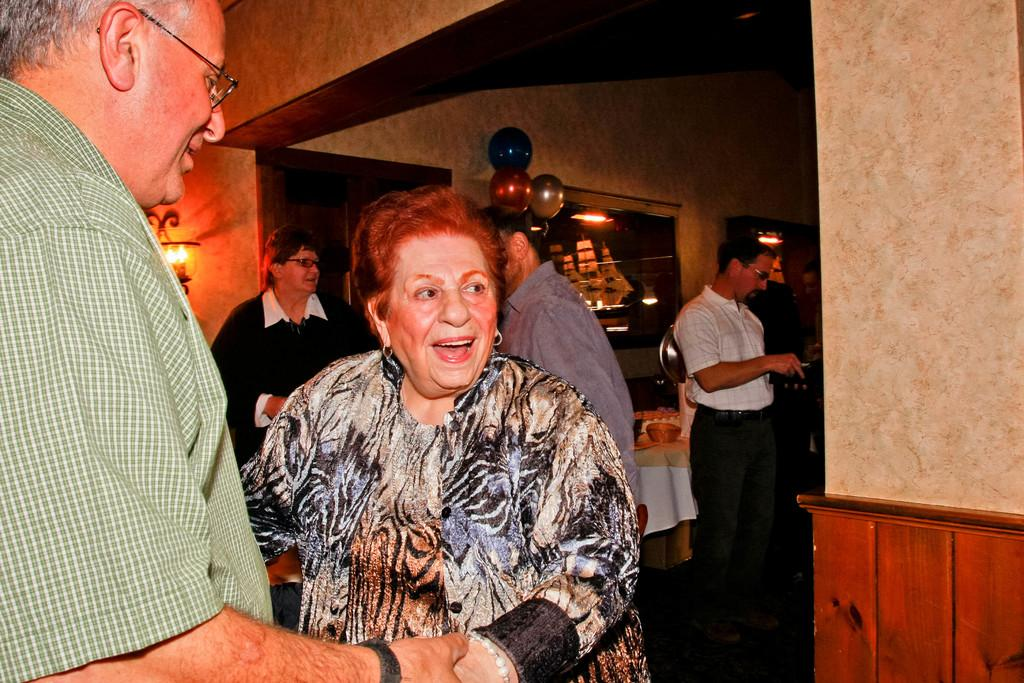How many persons can be seen in the image? There are persons standing in the image. What surface are the persons standing on? The persons are standing on the floor. What decorative item is hanging on a wall in the image? There is a wall hanging in the image. What type of objects are floating in the image? Balloons are present in the image. How many walls are visible in the image? There are walls visible in the image. Where is the electrical lamp located in the image? There is an electrical lamp attached to a wall in the image. What type of muscle can be seen flexing in the image? There is no muscle flexing visible in the image. What type of cloud formation can be seen in the image? There are no clouds present in the image. 